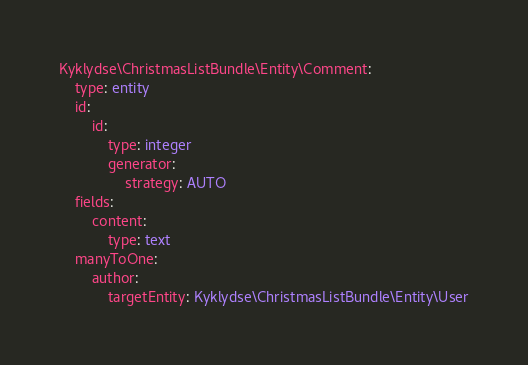Convert code to text. <code><loc_0><loc_0><loc_500><loc_500><_YAML_>Kyklydse\ChristmasListBundle\Entity\Comment:
    type: entity
    id:
        id:
            type: integer
            generator:
                strategy: AUTO
    fields:
        content:
            type: text
    manyToOne:
        author:
            targetEntity: Kyklydse\ChristmasListBundle\Entity\User
</code> 